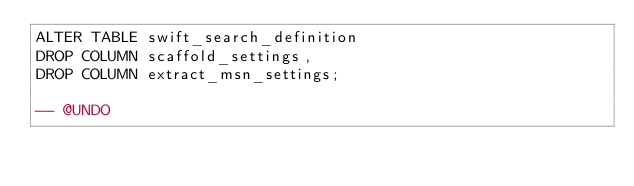Convert code to text. <code><loc_0><loc_0><loc_500><loc_500><_SQL_>ALTER TABLE swift_search_definition
DROP COLUMN scaffold_settings,
DROP COLUMN extract_msn_settings;

-- @UNDO

</code> 